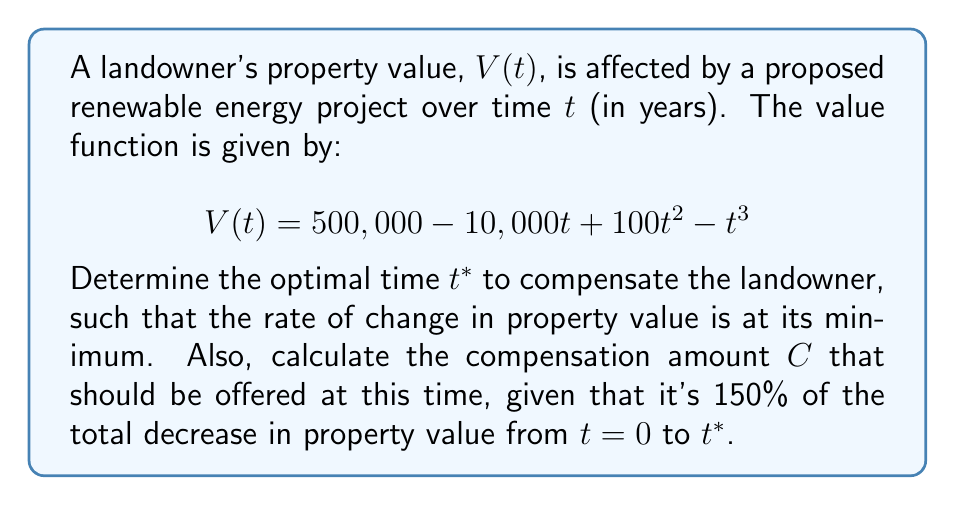Give your solution to this math problem. 1. To find the optimal time $t^*$, we need to find where the rate of change of property value is at its minimum. This occurs when the second derivative of $V(t)$ equals zero.

2. First, let's find the first derivative of $V(t)$:
   $$V'(t) = -10,000 + 200t - 3t^2$$

3. Now, let's find the second derivative:
   $$V''(t) = 200 - 6t$$

4. Set the second derivative to zero and solve for $t^*$:
   $$200 - 6t^* = 0$$
   $$-6t^* = -200$$
   $$t^* = \frac{200}{6} \approx 33.33 \text{ years}$$

5. To calculate the compensation amount, we need to find the total decrease in property value from $t=0$ to $t^*$:
   $$\Delta V = V(0) - V(t^*)$$
   $$V(0) = 500,000$$
   $$V(t^*) = 500,000 - 10,000(33.33) + 100(33.33)^2 - (33.33)^3$$
   $$V(t^*) \approx 388,889$$
   $$\Delta V \approx 500,000 - 388,889 = 111,111$$

6. The compensation amount $C$ is 150% of $\Delta V$:
   $$C = 1.5 \times 111,111 \approx 166,667$$
Answer: $t^* \approx 33.33$ years, $C \approx \$166,667$ 